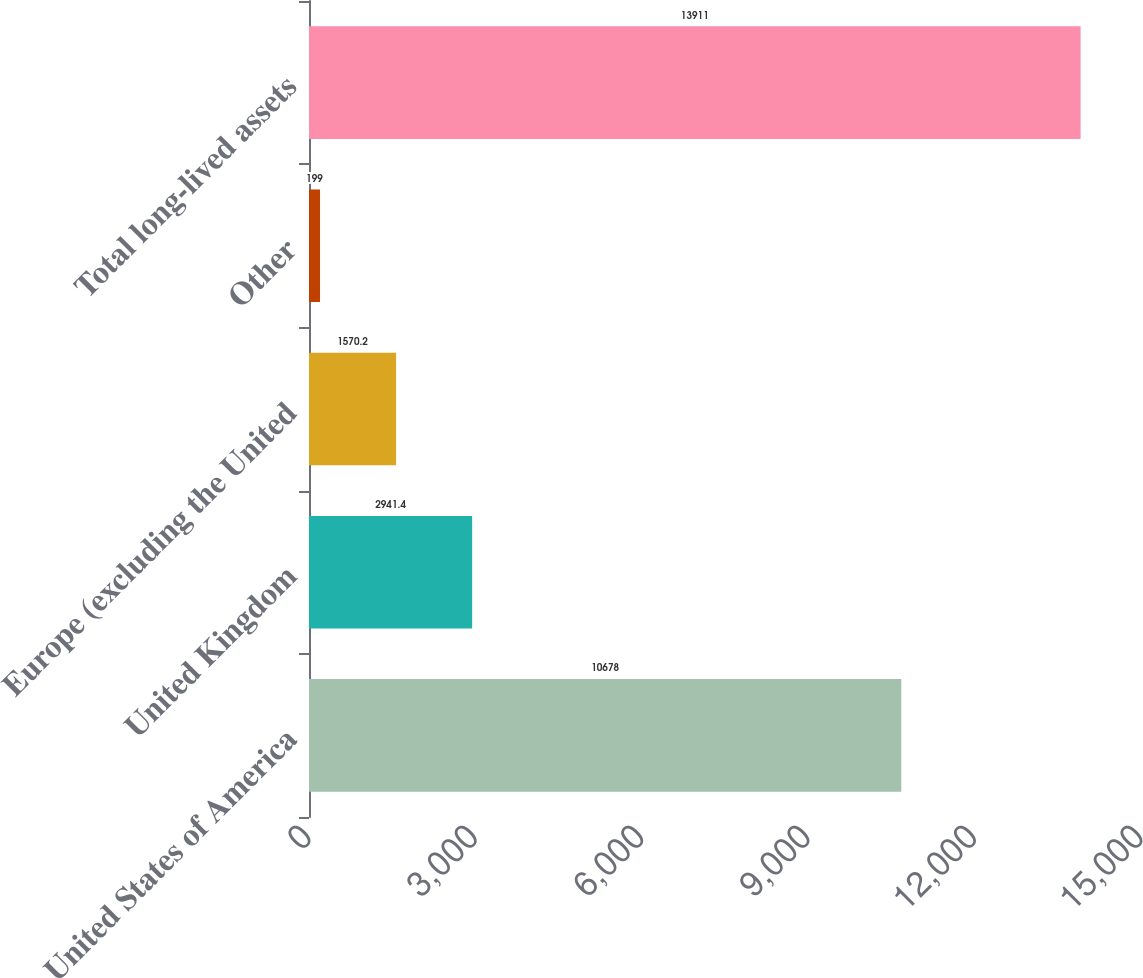Convert chart to OTSL. <chart><loc_0><loc_0><loc_500><loc_500><bar_chart><fcel>United States of America<fcel>United Kingdom<fcel>Europe (excluding the United<fcel>Other<fcel>Total long-lived assets<nl><fcel>10678<fcel>2941.4<fcel>1570.2<fcel>199<fcel>13911<nl></chart> 